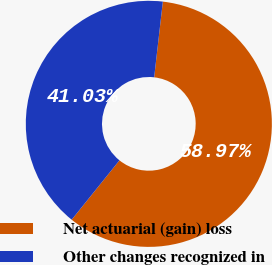Convert chart to OTSL. <chart><loc_0><loc_0><loc_500><loc_500><pie_chart><fcel>Net actuarial (gain) loss<fcel>Other changes recognized in<nl><fcel>58.97%<fcel>41.03%<nl></chart> 